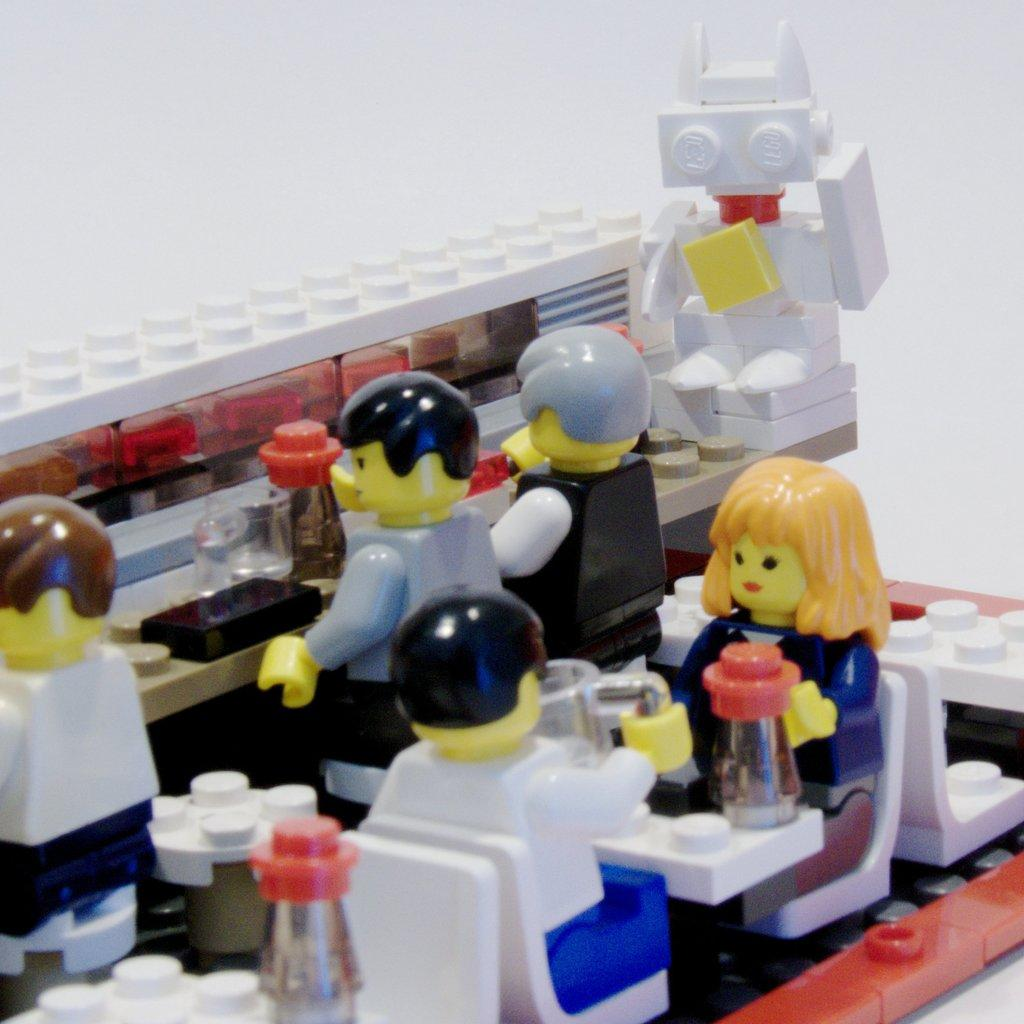What type of objects can be seen in the image? There are toys in the image. What type of butter is being spread on the top of the self in the image? There is no butter or self present in the image; it only features toys. 